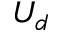<formula> <loc_0><loc_0><loc_500><loc_500>U _ { d }</formula> 